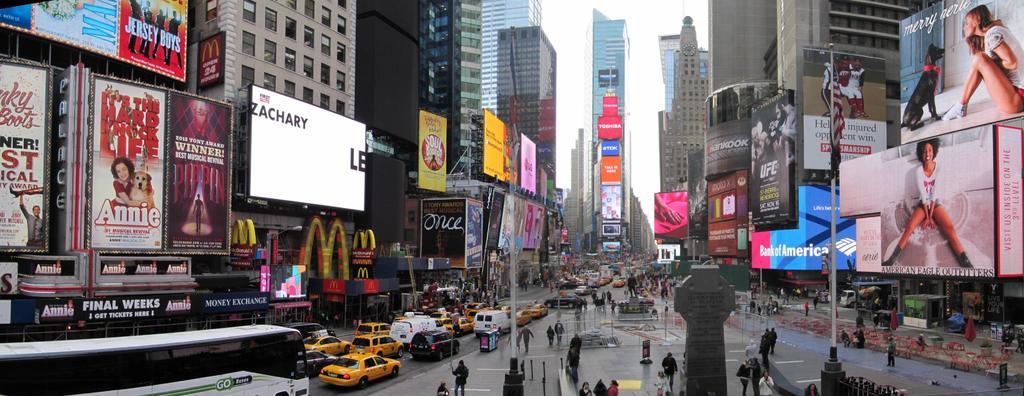What is the name of the play on the sign with a girl and a dog?
Make the answer very short. Annie. What fast food place has the big <?
Your response must be concise. Mcdonalds. 